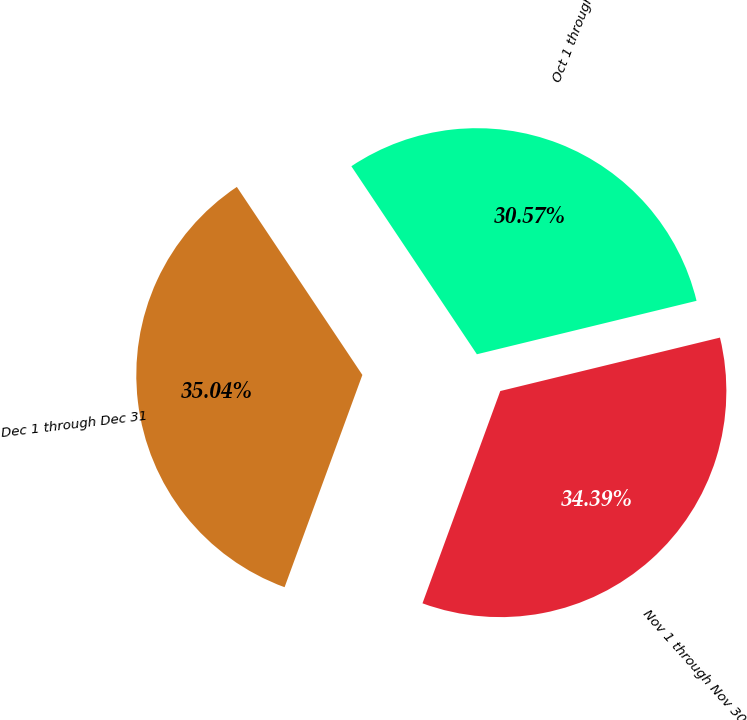<chart> <loc_0><loc_0><loc_500><loc_500><pie_chart><fcel>Oct 1 through Oct 31<fcel>Nov 1 through Nov 30<fcel>Dec 1 through Dec 31<nl><fcel>30.57%<fcel>34.39%<fcel>35.04%<nl></chart> 